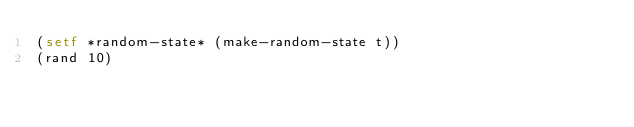Convert code to text. <code><loc_0><loc_0><loc_500><loc_500><_Lisp_>(setf *random-state* (make-random-state t))
(rand 10)
</code> 